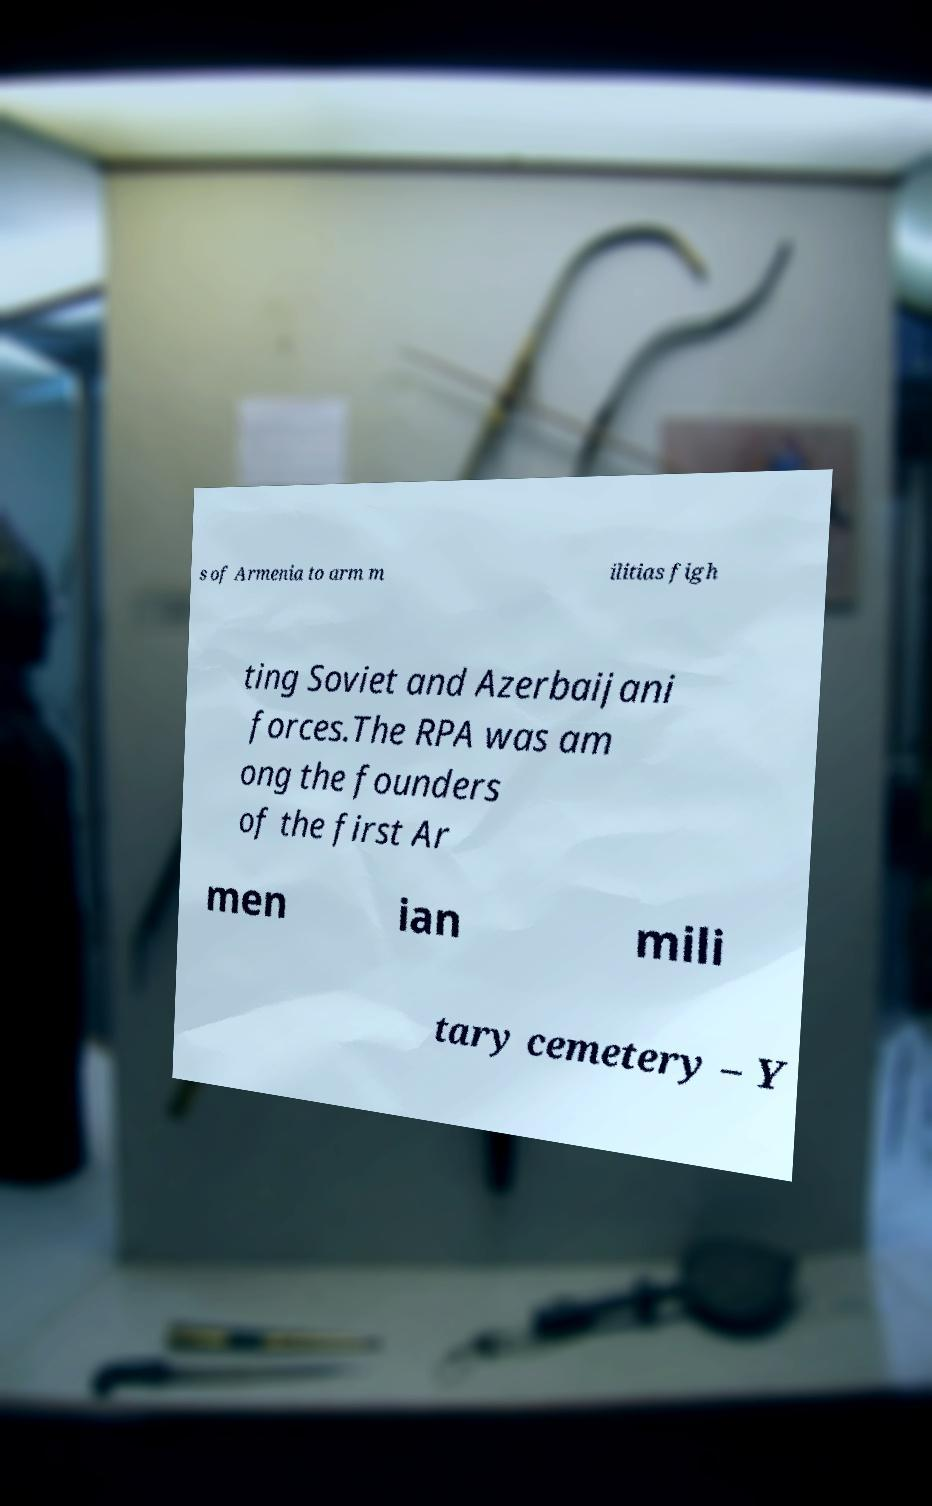Can you accurately transcribe the text from the provided image for me? s of Armenia to arm m ilitias figh ting Soviet and Azerbaijani forces.The RPA was am ong the founders of the first Ar men ian mili tary cemetery – Y 